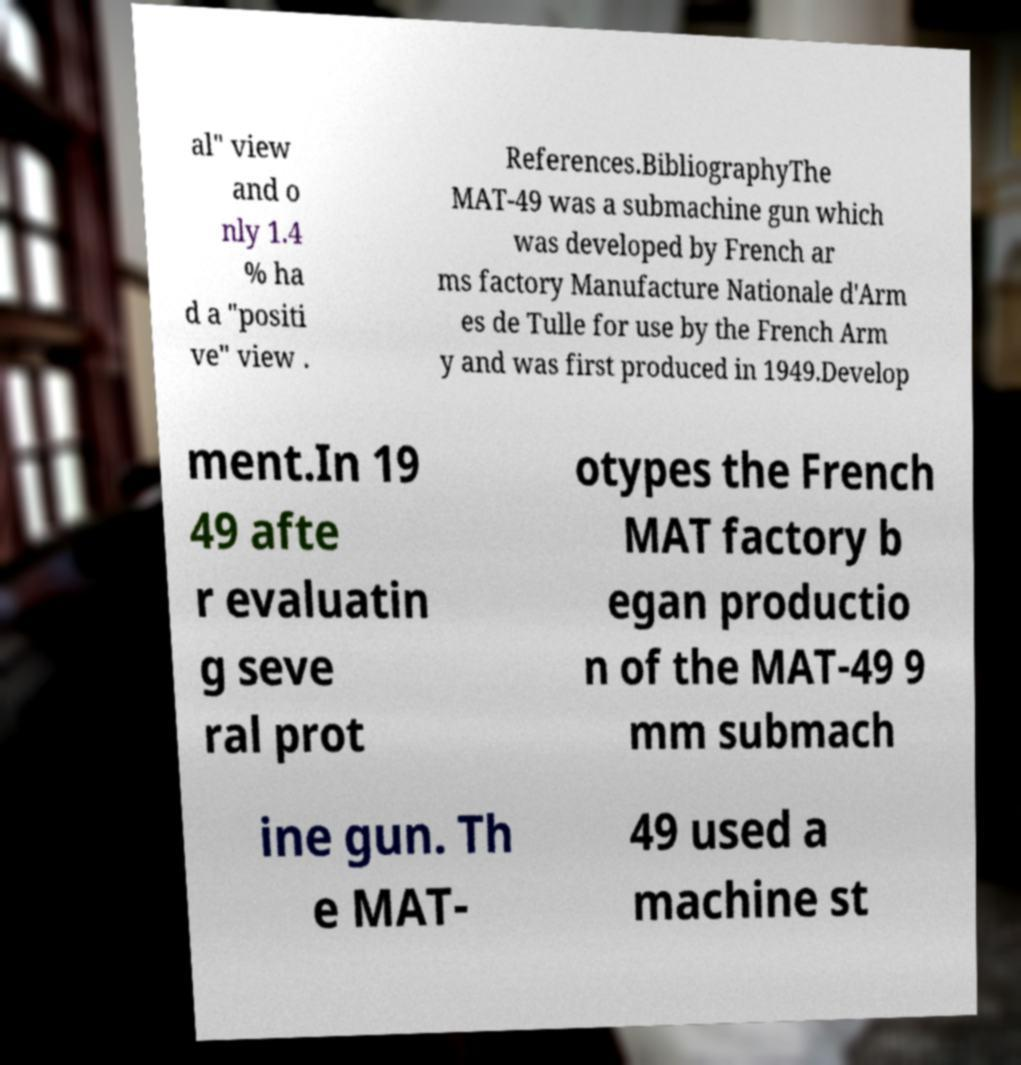What messages or text are displayed in this image? I need them in a readable, typed format. al" view and o nly 1.4 % ha d a "positi ve" view . References.BibliographyThe MAT-49 was a submachine gun which was developed by French ar ms factory Manufacture Nationale d'Arm es de Tulle for use by the French Arm y and was first produced in 1949.Develop ment.In 19 49 afte r evaluatin g seve ral prot otypes the French MAT factory b egan productio n of the MAT-49 9 mm submach ine gun. Th e MAT- 49 used a machine st 